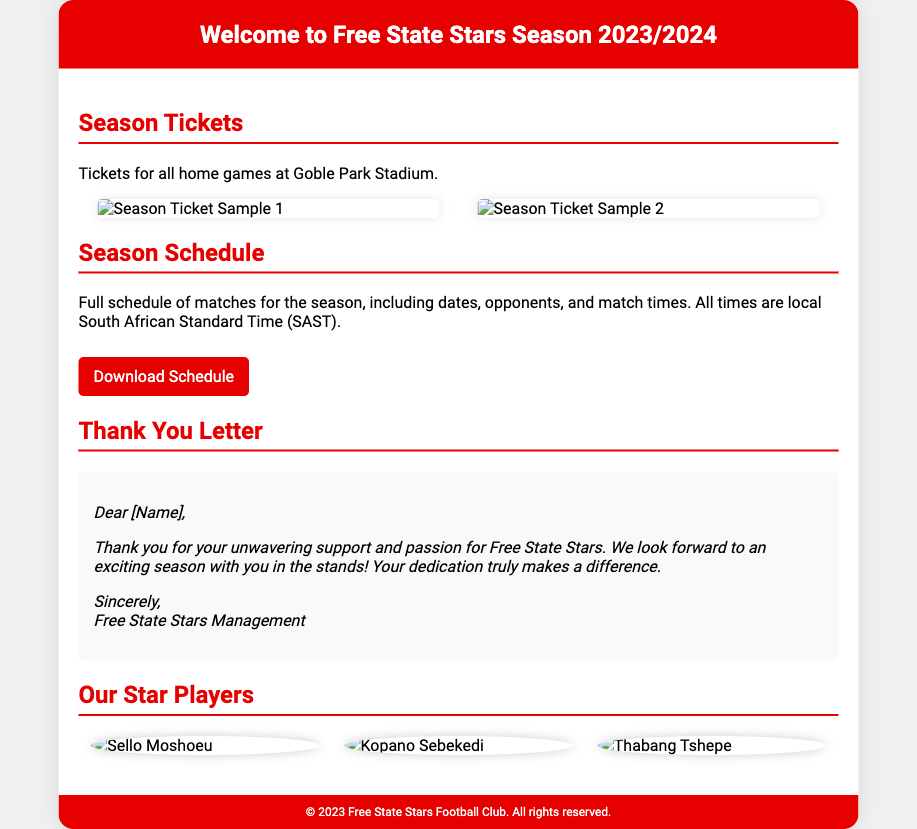what is included in the Season Ticket Holder's Welcome Package? The Welcome Package contains tickets for all home games, the season schedule, and a personalized thank you letter.
Answer: tickets for all home games, the season schedule, and a personalized thank you letter where are the home games played? The document states that home games are held at Goble Park Stadium.
Answer: Goble Park Stadium how many star players are featured in the document? There are three star players highlighted in the document.
Answer: three what color is the header background? The header background color specified in the document is #e60000.
Answer: #e60000 what is the purpose of the thank you letter? The thank you letter expresses gratitude for the support and passion for Free State Stars and looks forward to the season.
Answer: gratitude for support what does the Season Schedule contain? The Season Schedule includes a full schedule of matches, dates, opponents, and match times.
Answer: full schedule of matches, dates, opponents, and match times what images are used in the design? The design features images of the team's star players.
Answer: images of the team's star players what is the tone of the thank you letter? The tone of the thank you letter is appreciative and positive.
Answer: appreciative and positive what type of document is this? The document is a product packaging specifically for season ticket holders.
Answer: product packaging for season ticket holders 